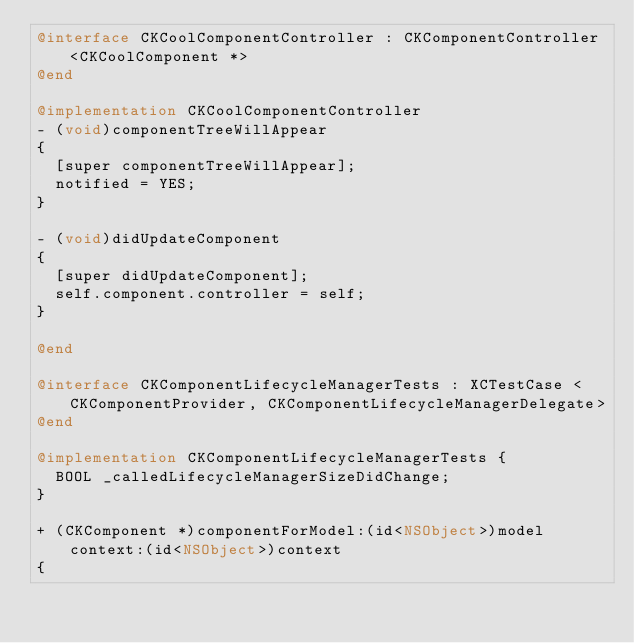Convert code to text. <code><loc_0><loc_0><loc_500><loc_500><_ObjectiveC_>@interface CKCoolComponentController : CKComponentController<CKCoolComponent *>
@end

@implementation CKCoolComponentController
- (void)componentTreeWillAppear
{
  [super componentTreeWillAppear];
  notified = YES;
}

- (void)didUpdateComponent
{
  [super didUpdateComponent];
  self.component.controller = self;
}

@end

@interface CKComponentLifecycleManagerTests : XCTestCase <CKComponentProvider, CKComponentLifecycleManagerDelegate>
@end

@implementation CKComponentLifecycleManagerTests {
  BOOL _calledLifecycleManagerSizeDidChange;
}

+ (CKComponent *)componentForModel:(id<NSObject>)model context:(id<NSObject>)context
{</code> 